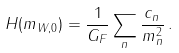<formula> <loc_0><loc_0><loc_500><loc_500>H ( m _ { W , 0 } ) = \frac { 1 } { G _ { F } } \sum _ { n } \frac { c _ { n } } { m _ { n } ^ { 2 } } \, .</formula> 